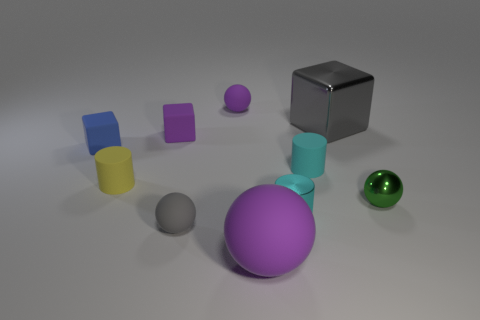Does the cyan metal object have the same shape as the yellow object that is to the left of the big metallic block?
Offer a terse response. Yes. What number of other objects are the same size as the green object?
Make the answer very short. 7. What size is the purple sphere that is in front of the gray matte sphere?
Keep it short and to the point. Large. How many small purple spheres have the same material as the purple block?
Provide a short and direct response. 1. There is a blue rubber object behind the gray sphere; does it have the same shape as the small gray rubber thing?
Offer a very short reply. No. What is the shape of the tiny purple matte thing that is in front of the big gray metal block?
Your answer should be very brief. Cube. What is the size of the other cylinder that is the same color as the metal cylinder?
Your response must be concise. Small. What material is the gray sphere?
Keep it short and to the point. Rubber. What color is the matte cylinder that is the same size as the yellow rubber object?
Ensure brevity in your answer.  Cyan. What shape is the object that is the same color as the shiny cylinder?
Provide a short and direct response. Cylinder. 